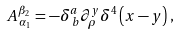Convert formula to latex. <formula><loc_0><loc_0><loc_500><loc_500>A _ { \, \alpha _ { 1 } } ^ { \beta _ { 2 } } = - \delta _ { \, b } ^ { a } \partial _ { \rho } ^ { y } \delta ^ { 4 } \left ( x - y \right ) ,</formula> 